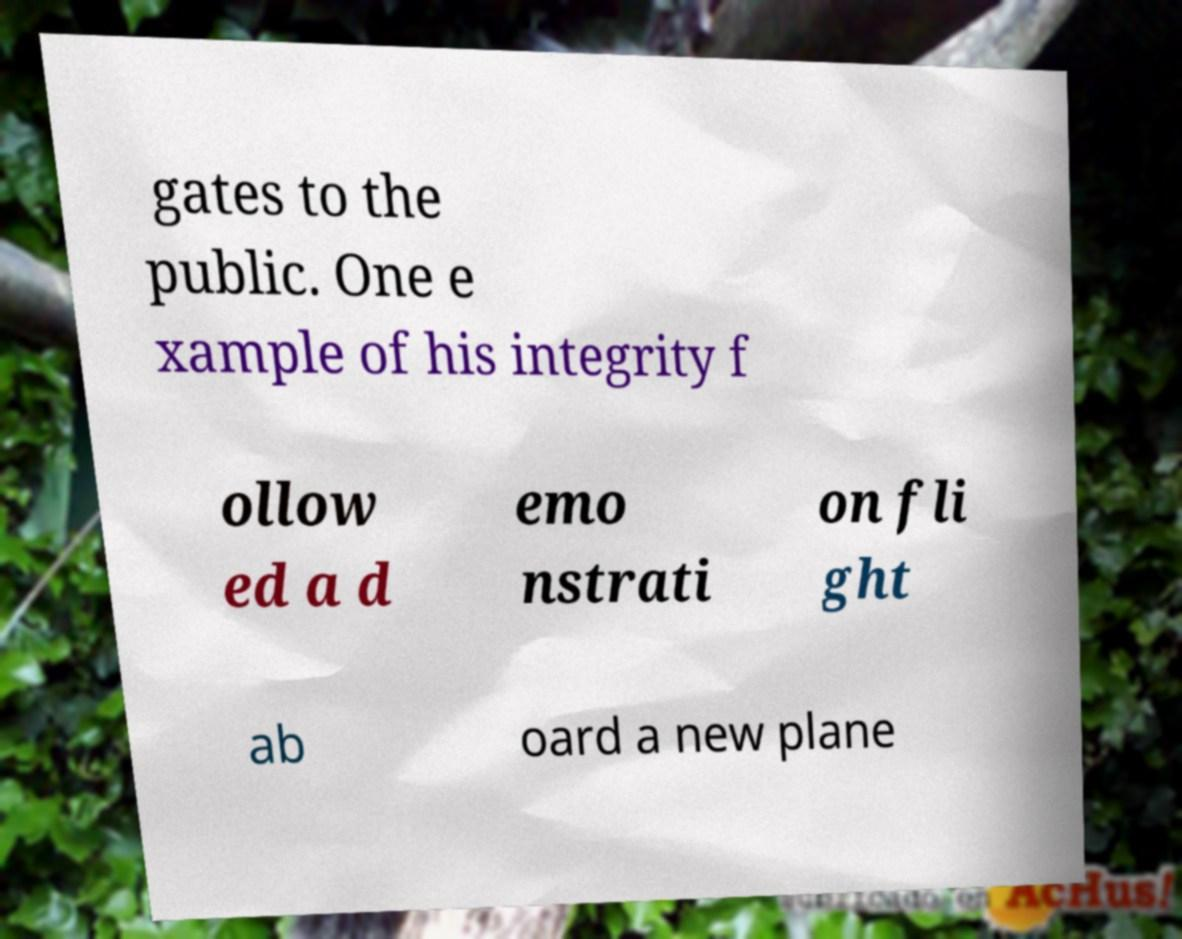For documentation purposes, I need the text within this image transcribed. Could you provide that? gates to the public. One e xample of his integrity f ollow ed a d emo nstrati on fli ght ab oard a new plane 